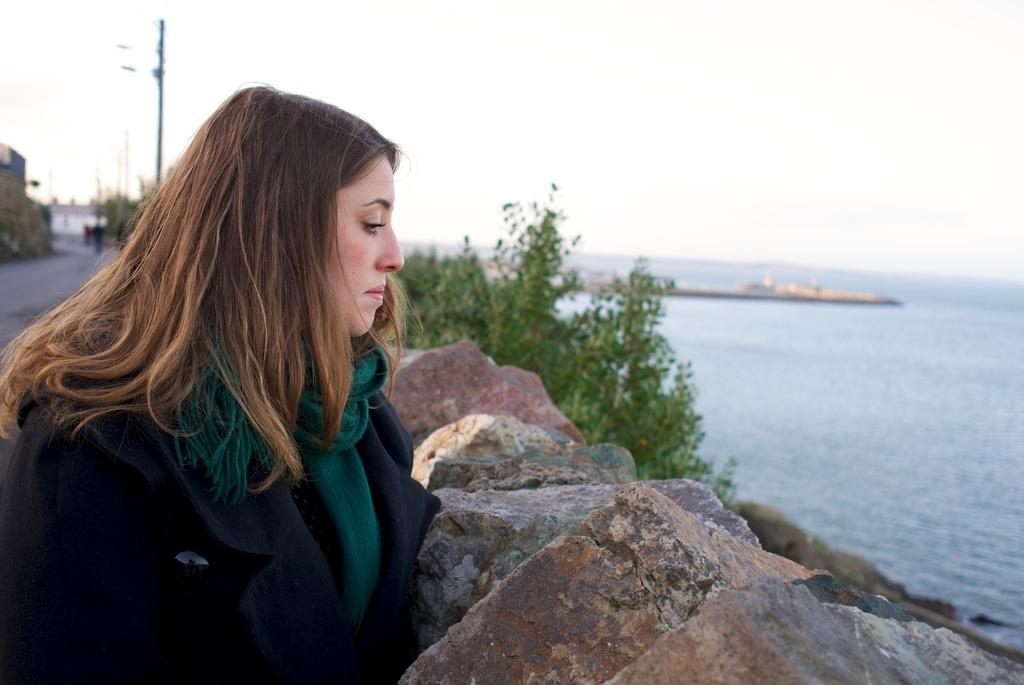What is the position of the woman in the image? The woman is standing on the left side of the image. What is the woman standing on? The woman is standing on stones. What can be seen in the background of the image? There are trees, water, a ship, a building, and poles visible in the background of the image. What part of the natural environment is visible in the image? The sky is visible in the background of the image. What type of butter is being used to grease the poles in the image? There is no butter present in the image, nor is there any indication that the poles are being greased. 